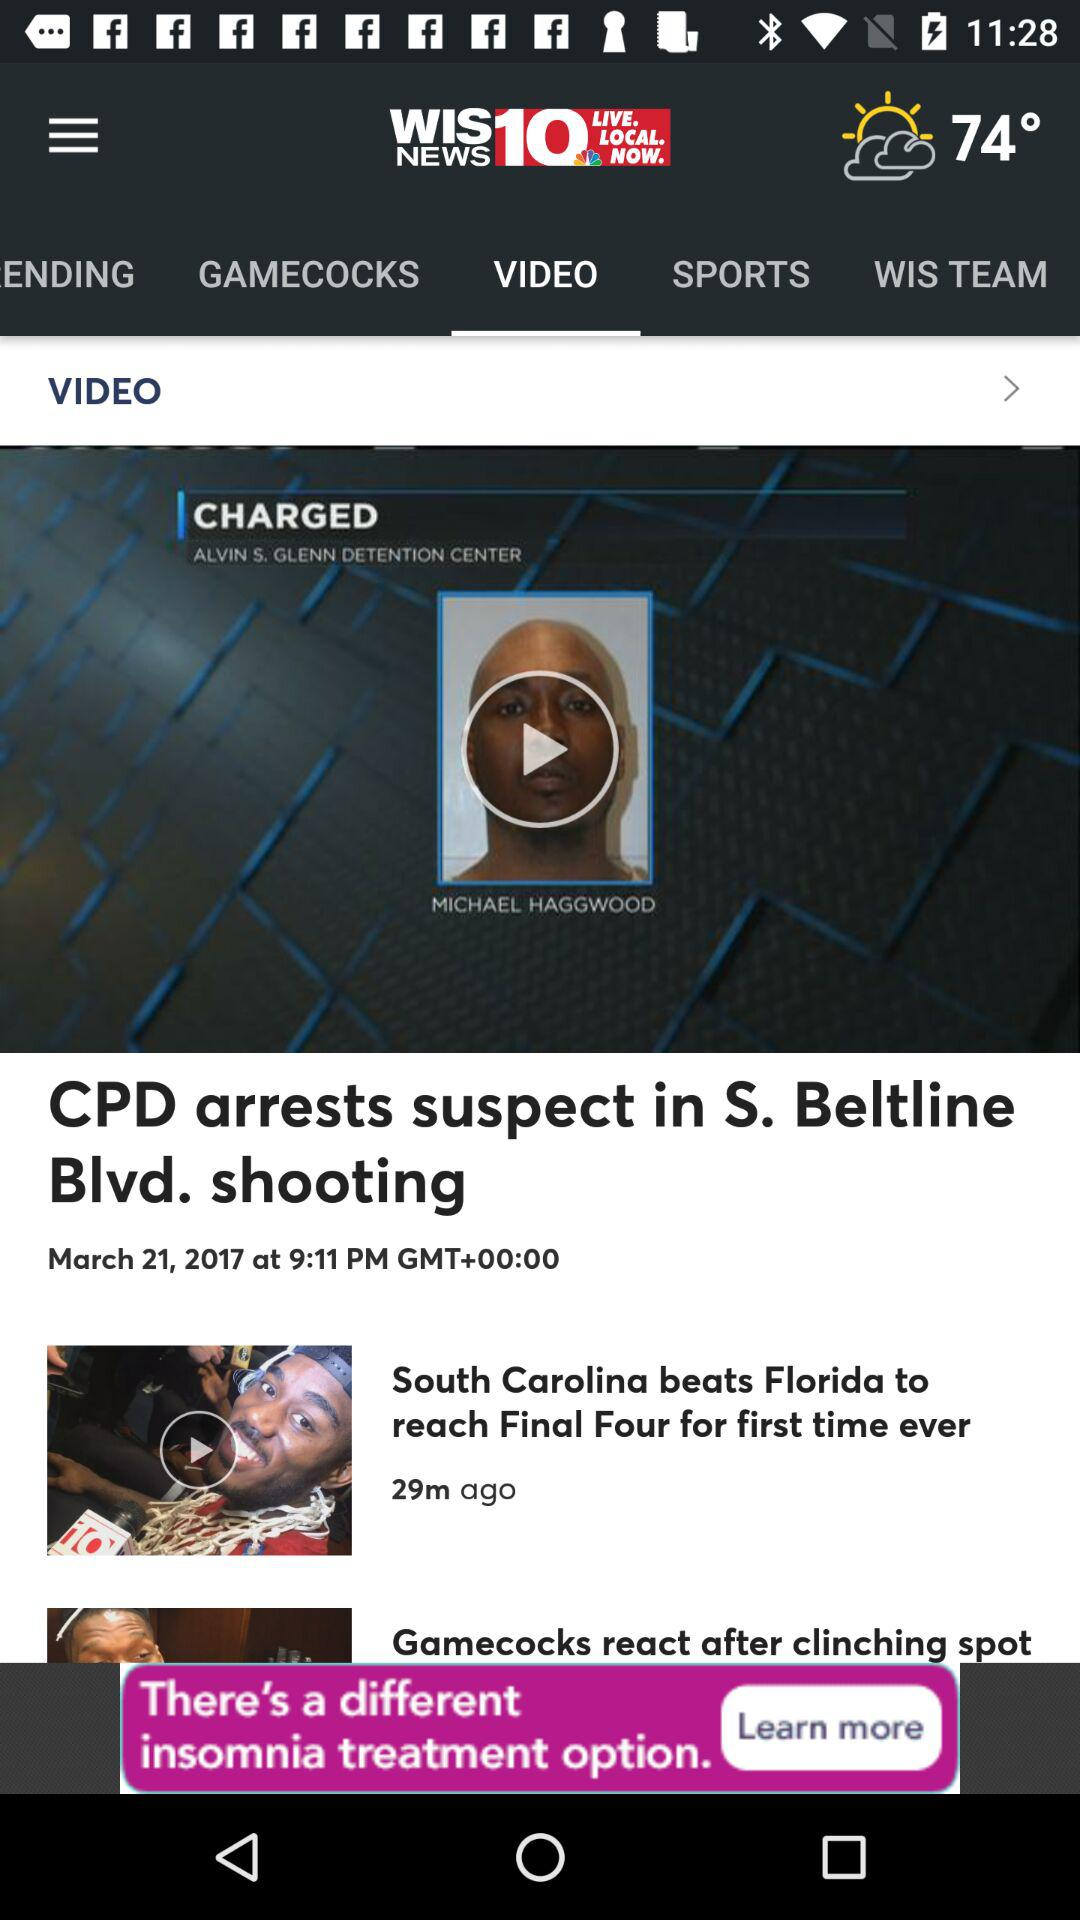Which tab is selected? The selected tab is "VIDEO". 